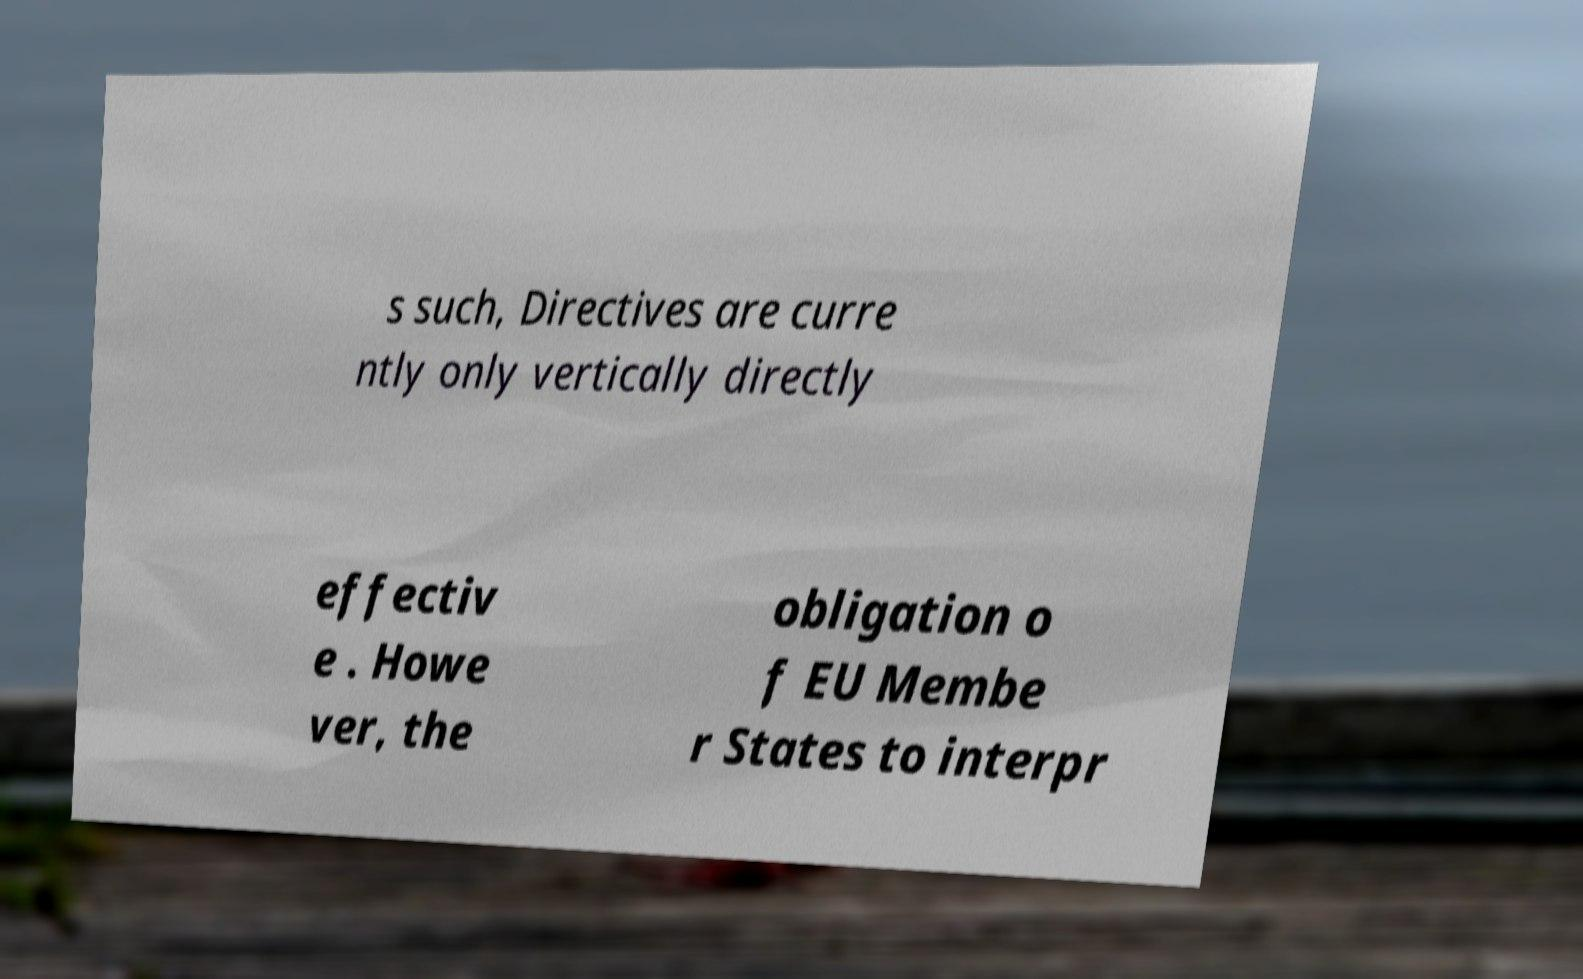Please read and relay the text visible in this image. What does it say? s such, Directives are curre ntly only vertically directly effectiv e . Howe ver, the obligation o f EU Membe r States to interpr 